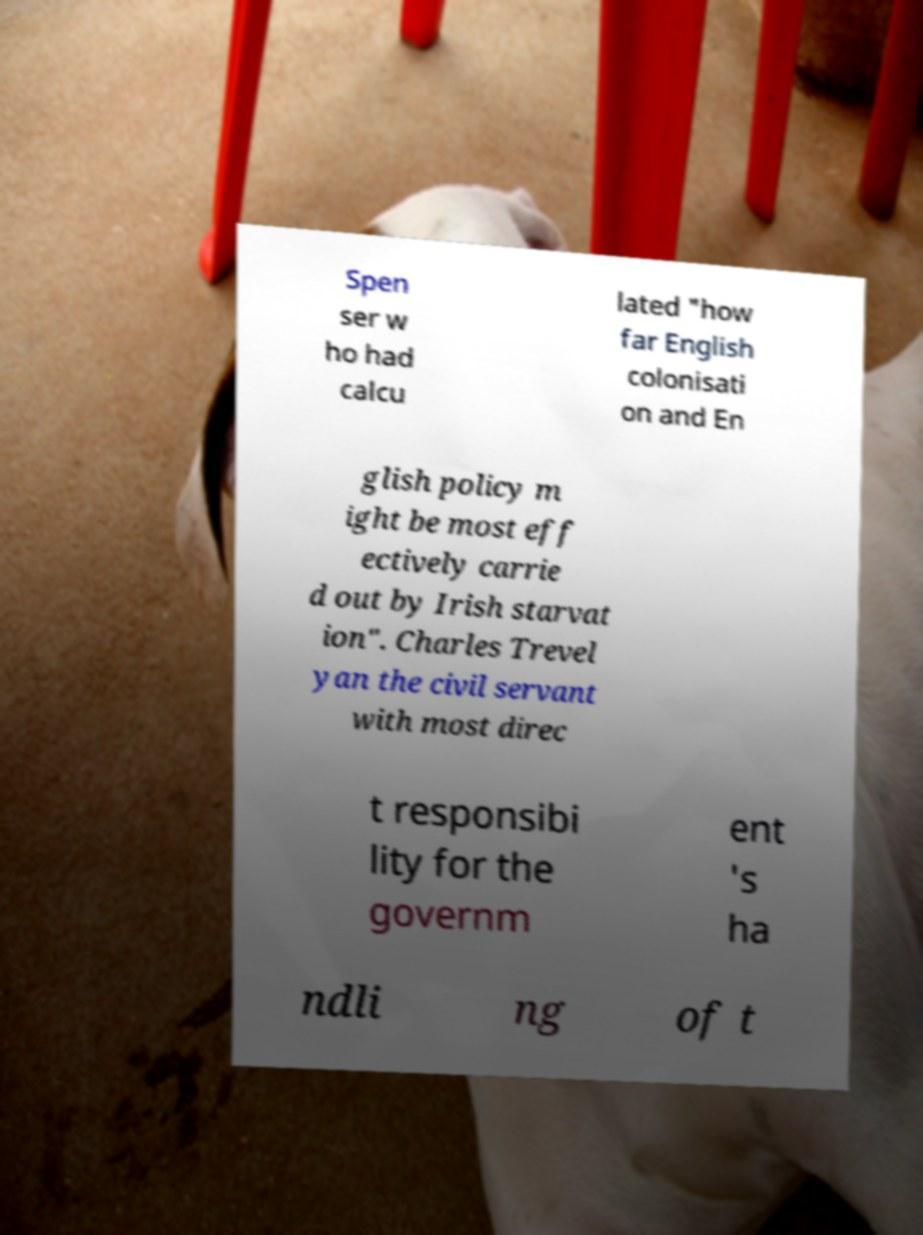Can you read and provide the text displayed in the image?This photo seems to have some interesting text. Can you extract and type it out for me? Spen ser w ho had calcu lated "how far English colonisati on and En glish policy m ight be most eff ectively carrie d out by Irish starvat ion". Charles Trevel yan the civil servant with most direc t responsibi lity for the governm ent 's ha ndli ng of t 